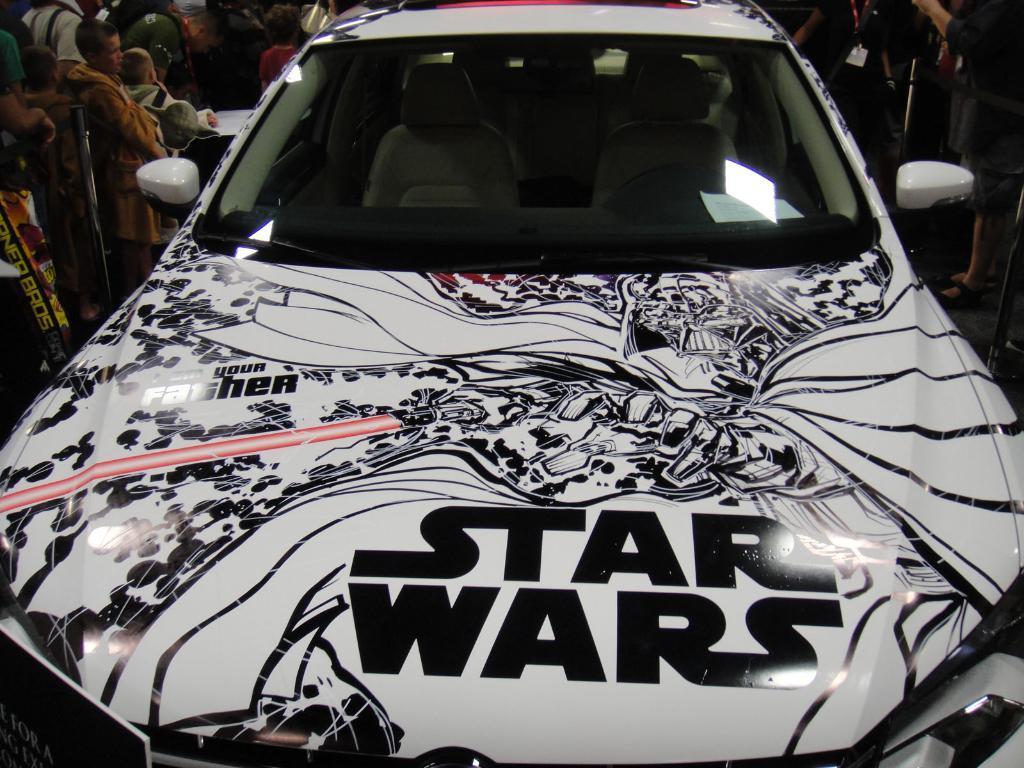Describe this image in one or two sentences. In this image I can see a car and on the car I can see design and both sides of the car I can see persons. 